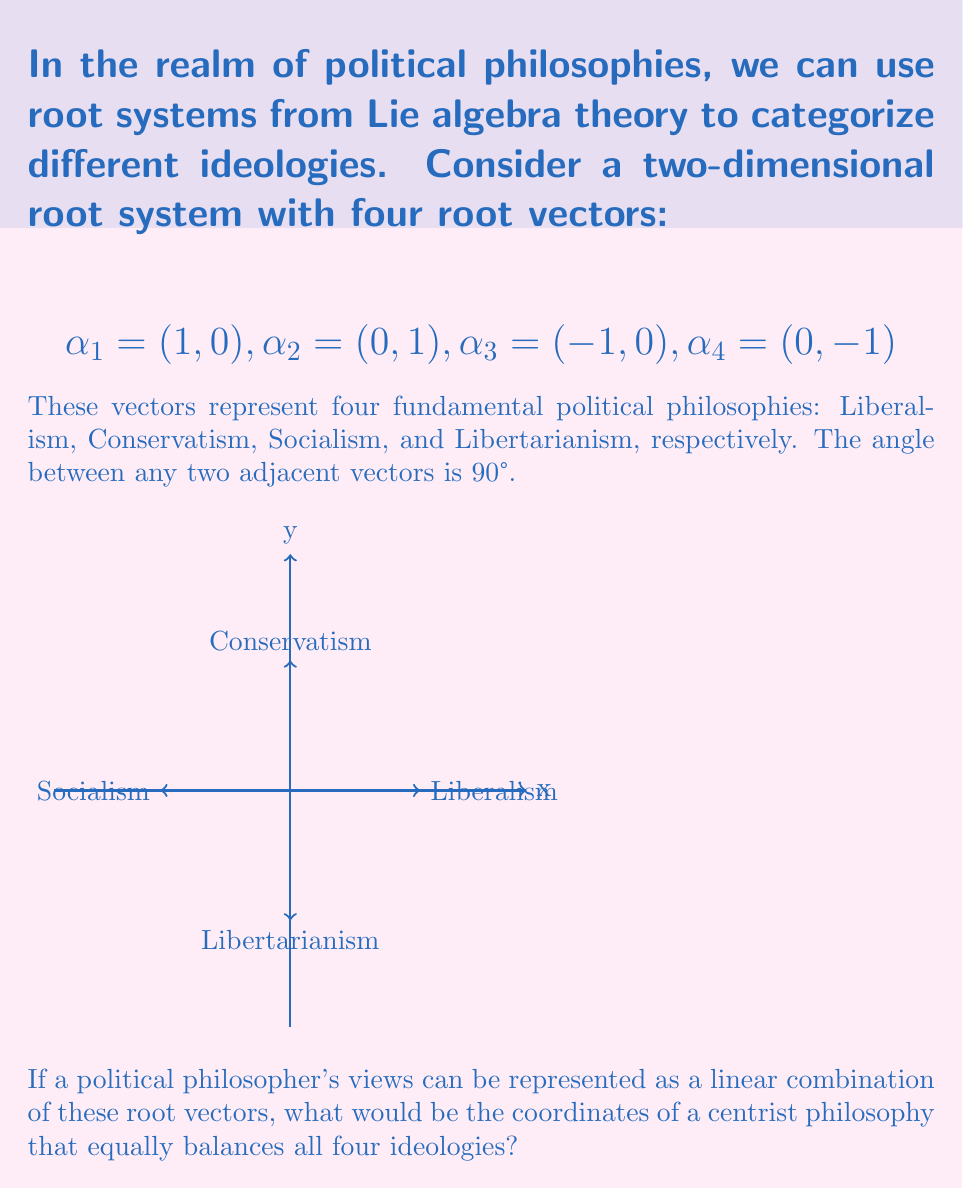Solve this math problem. To solve this problem, we need to follow these steps:

1) A centrist philosophy that equally balances all four ideologies would give equal weight to each root vector. Let's call this weight $w$.

2) The centrist philosophy vector $v$ would be the sum of all four root vectors, each multiplied by $w$:

   $v = w\alpha_1 + w\alpha_2 + w\alpha_3 + w\alpha_4$

3) Substituting the values of the root vectors:

   $v = w(1,0) + w(0,1) + w(-1,0) + w(0,-1)$

4) Simplifying:

   $v = (w-w, w-w) = (0,0)$

5) This result shows that regardless of the value of $w$, a perfectly balanced centrist philosophy would be represented by the origin (0,0) in this root system.

6) In terms of political interpretation, this means that a true centrist philosophy, by equally embracing all four fundamental ideologies, would effectively neutralize their opposing tendencies, resulting in a balanced, moderate stance at the center of the political spectrum.
Answer: (0,0) 